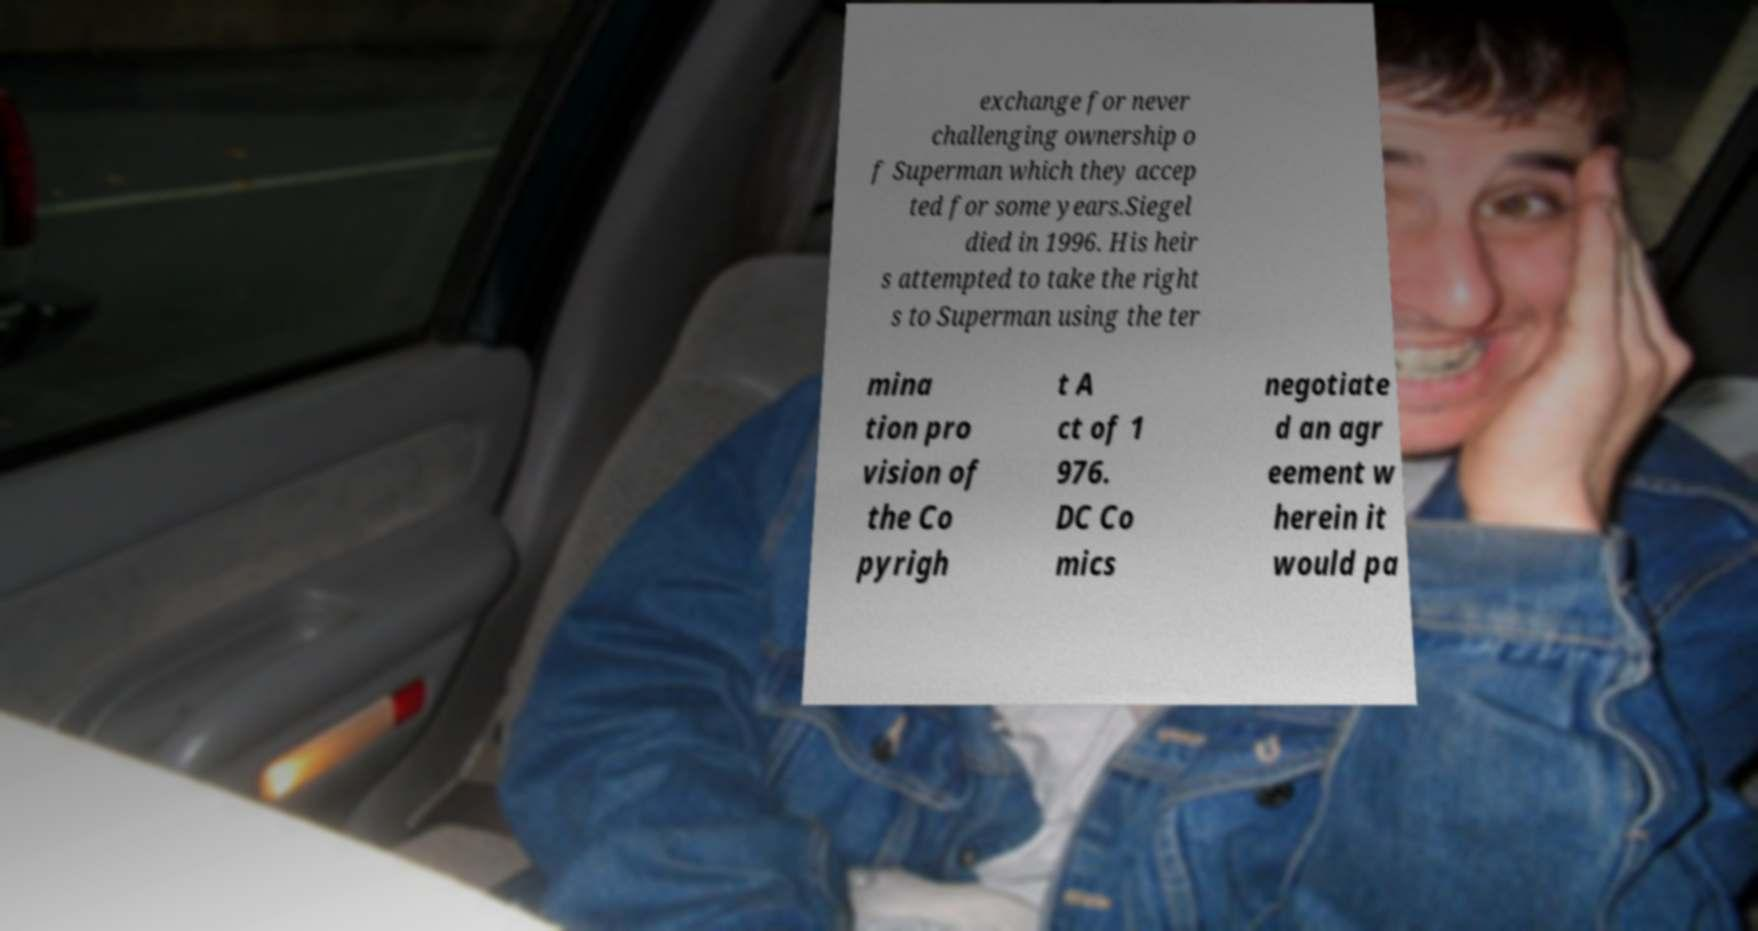There's text embedded in this image that I need extracted. Can you transcribe it verbatim? exchange for never challenging ownership o f Superman which they accep ted for some years.Siegel died in 1996. His heir s attempted to take the right s to Superman using the ter mina tion pro vision of the Co pyrigh t A ct of 1 976. DC Co mics negotiate d an agr eement w herein it would pa 